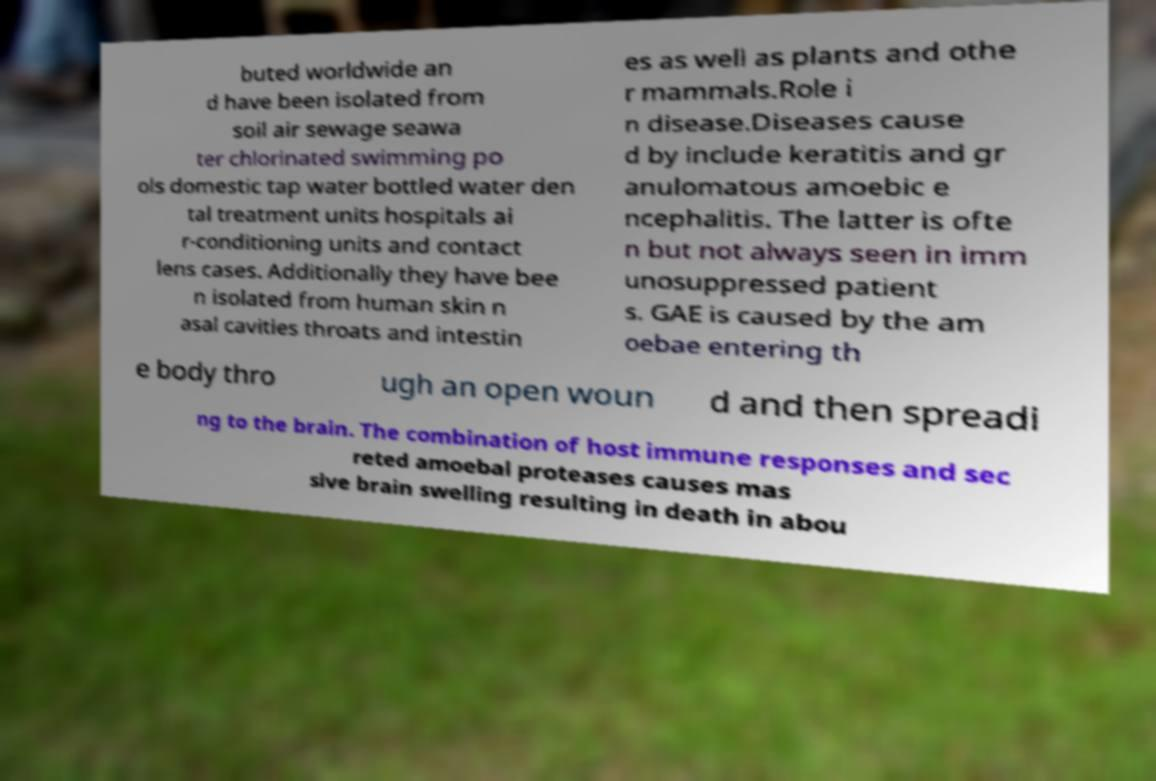Can you read and provide the text displayed in the image?This photo seems to have some interesting text. Can you extract and type it out for me? buted worldwide an d have been isolated from soil air sewage seawa ter chlorinated swimming po ols domestic tap water bottled water den tal treatment units hospitals ai r-conditioning units and contact lens cases. Additionally they have bee n isolated from human skin n asal cavities throats and intestin es as well as plants and othe r mammals.Role i n disease.Diseases cause d by include keratitis and gr anulomatous amoebic e ncephalitis. The latter is ofte n but not always seen in imm unosuppressed patient s. GAE is caused by the am oebae entering th e body thro ugh an open woun d and then spreadi ng to the brain. The combination of host immune responses and sec reted amoebal proteases causes mas sive brain swelling resulting in death in abou 